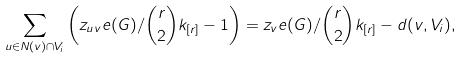Convert formula to latex. <formula><loc_0><loc_0><loc_500><loc_500>\sum _ { u \in N ( v ) \cap V _ { i } } \left ( z _ { u v } e ( G ) / \binom { r } { 2 } k _ { [ r ] } - 1 \right ) = z _ { v } e ( G ) / \binom { r } { 2 } k _ { [ r ] } - d ( v , V _ { i } ) ,</formula> 